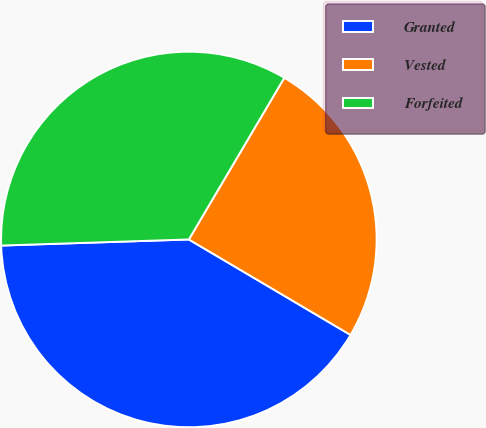<chart> <loc_0><loc_0><loc_500><loc_500><pie_chart><fcel>Granted<fcel>Vested<fcel>Forfeited<nl><fcel>40.99%<fcel>25.0%<fcel>34.0%<nl></chart> 